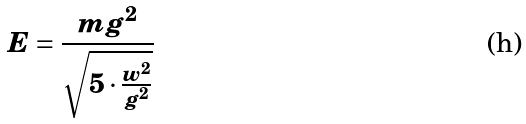<formula> <loc_0><loc_0><loc_500><loc_500>E = \frac { m g ^ { 2 } } { \sqrt { 5 \cdot \frac { w ^ { 2 } } { g ^ { 2 } } } }</formula> 